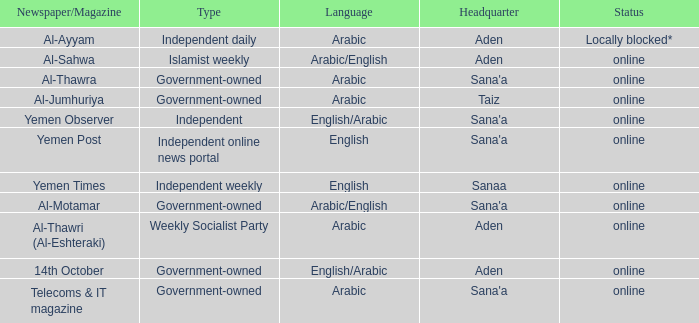What is Headquarter, when Newspaper/Magazine is Al-Ayyam? Aden. 